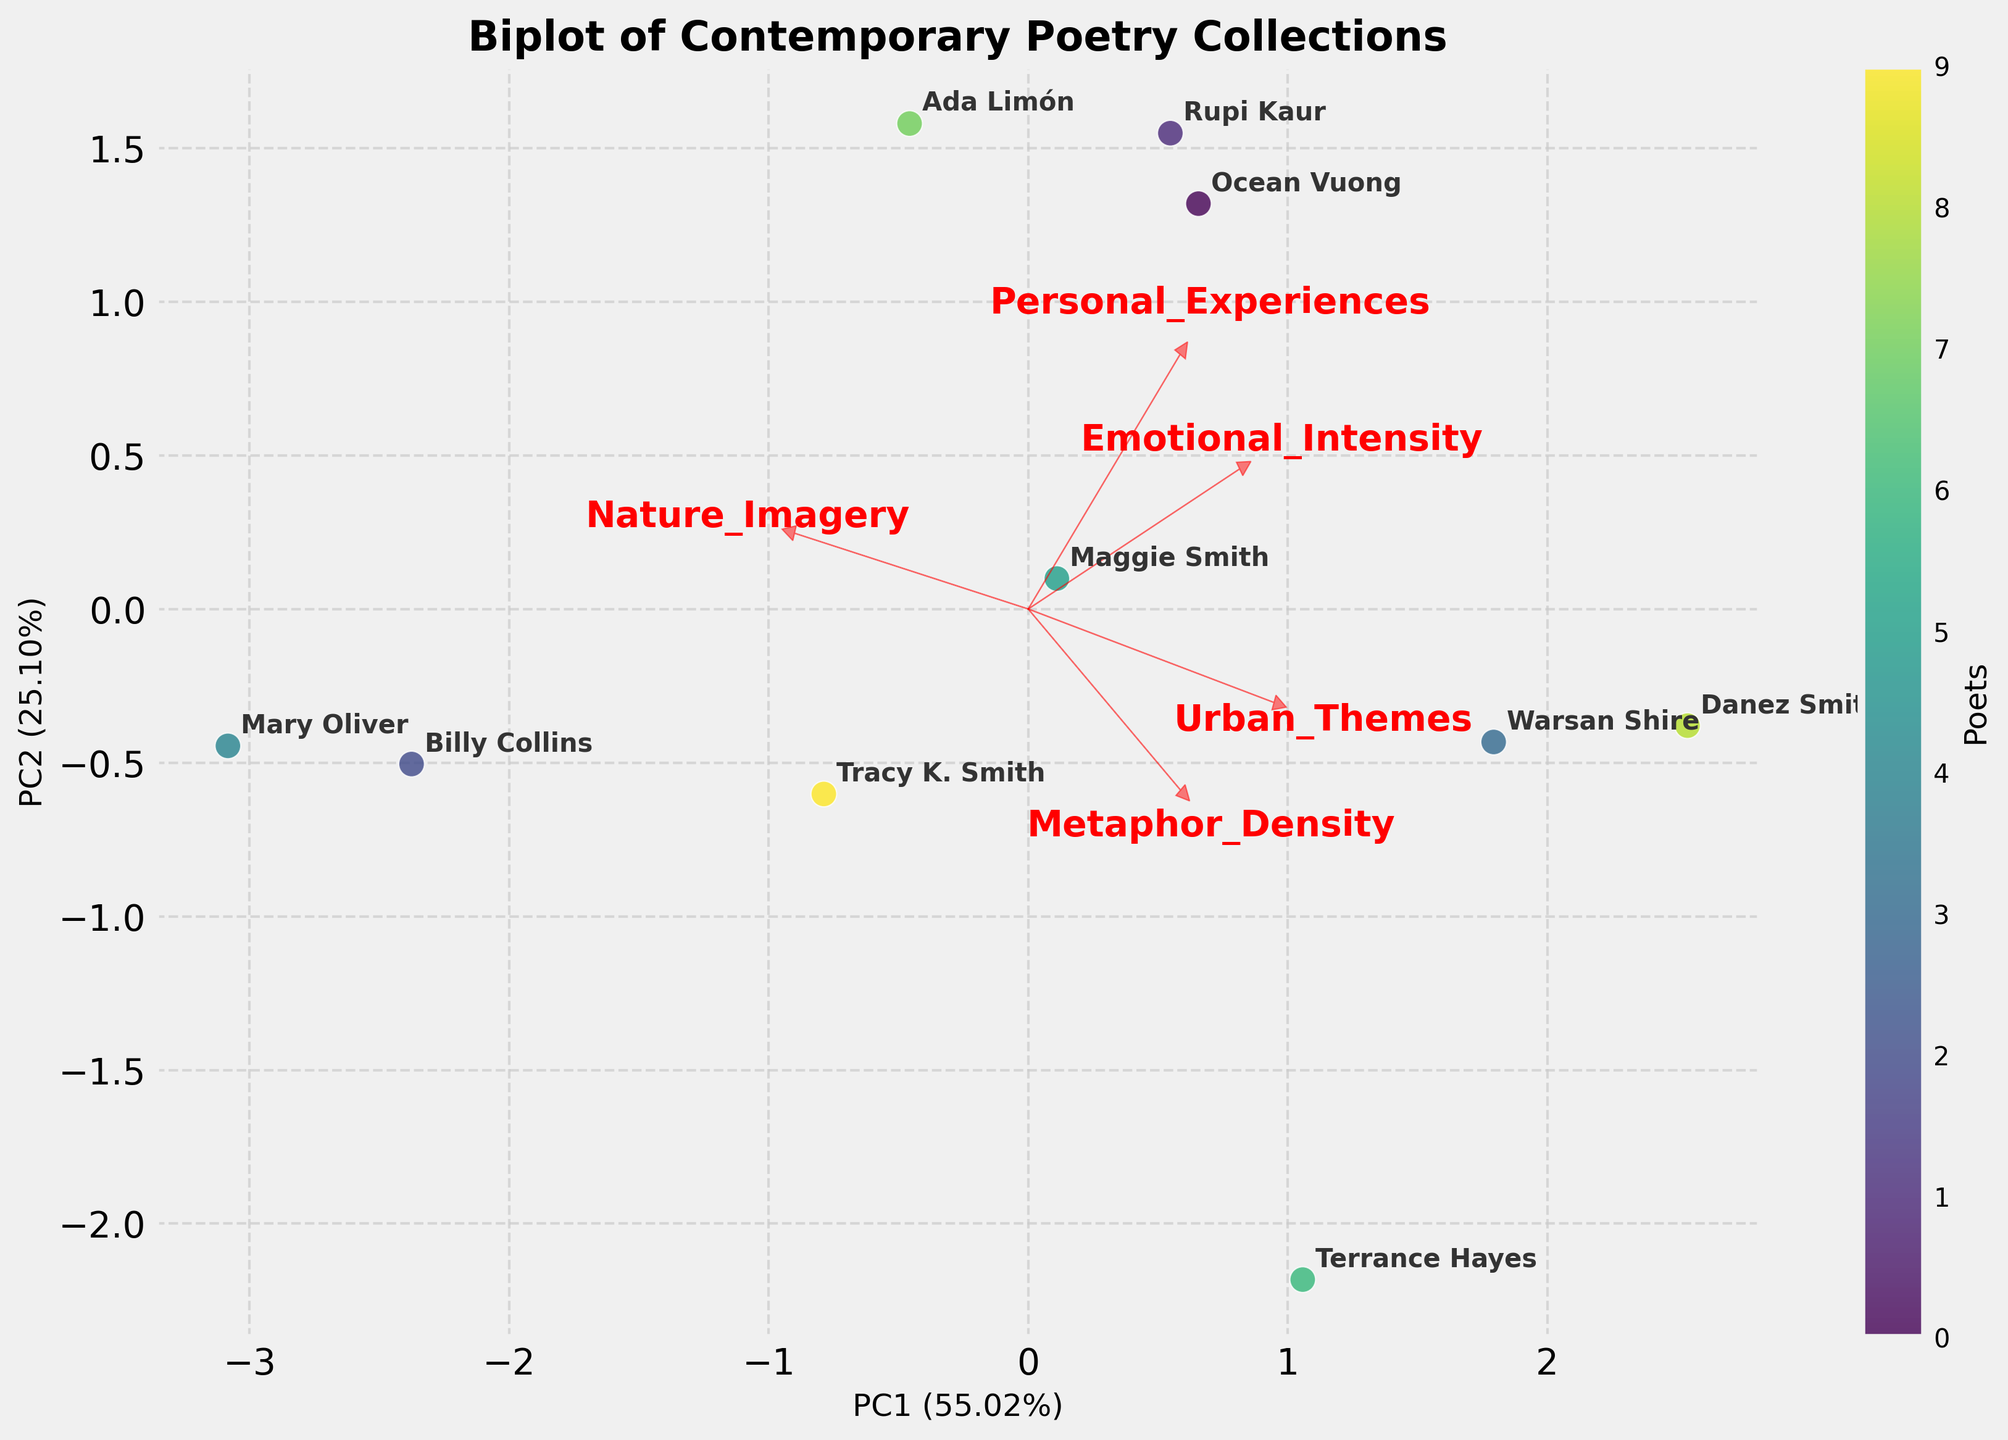What are the labels on the x-axis and y-axis? The labels on the x-axis and y-axis come from the PCA components calculated from the standardized data. In this biplot, the x-axis label is PC1 along with its explained variance percentage, and the y-axis is PC2 along with its explained variance percentage.
Answer: PC1 and PC2 with their respective percentages How many poets are plotted on the biplot? To find out how many poets are plotted, you count the number of unique points or annotations on the biplot. Each point or label corresponds to a poet's data.
Answer: 10 Which poet is located furthest to the right on the biplot? The furthest right poet can be identified by looking at the point that has the highest value on the PC1 axis.
Answer: Danez Smith Are there any poets that cluster closely together? Clusters can be identified by looking for points that are near each other. In this biplot, you need to visually inspect which poets' points are very close.
Answer: Ocean Vuong and Warsan Shire Which poet appears to have the highest combination of metaphor density and emotional intensity? You will look for the poet whose position aligns closest with the direction of the arrows representing "Metaphor_Density" and "Emotional_Intensity."
Answer: Warsan Shire How much variance is explained by PC1 and PC2 together? Variance explained can be found by adding the percentages from PC1 and PC2 mentioned on the axes. E.g., if PC1 explains 60% and PC2 25%, their sum is the total variance explained by the first two components.
Answer: Sum of explained variance percentages for PC1 and PC2 How does the nature imagery feature compare to urban themes in their contribution to principal components? Compare the length and direction of the arrows for "Nature_Imagery" and "Urban_Themes." You would look at the relative positions and arrow lengths to each other.
Answer: Nature_Imagery has a larger contribution compared to Urban_Themes Which poet has a balanced contribution from all features? A poet with a balanced influence from all features would sit nearer to the center where the arrowheads converge; this would mean no single feature hugely dominates.
Answer: Tracy K. Smith Who are the two poets most associated with urban themes based on their position? Look for poets positioned in the direction of the "Urban_Themes" arrow, considering how far they are along that vector.
Answer: Danez Smith and Terrance Hayes 